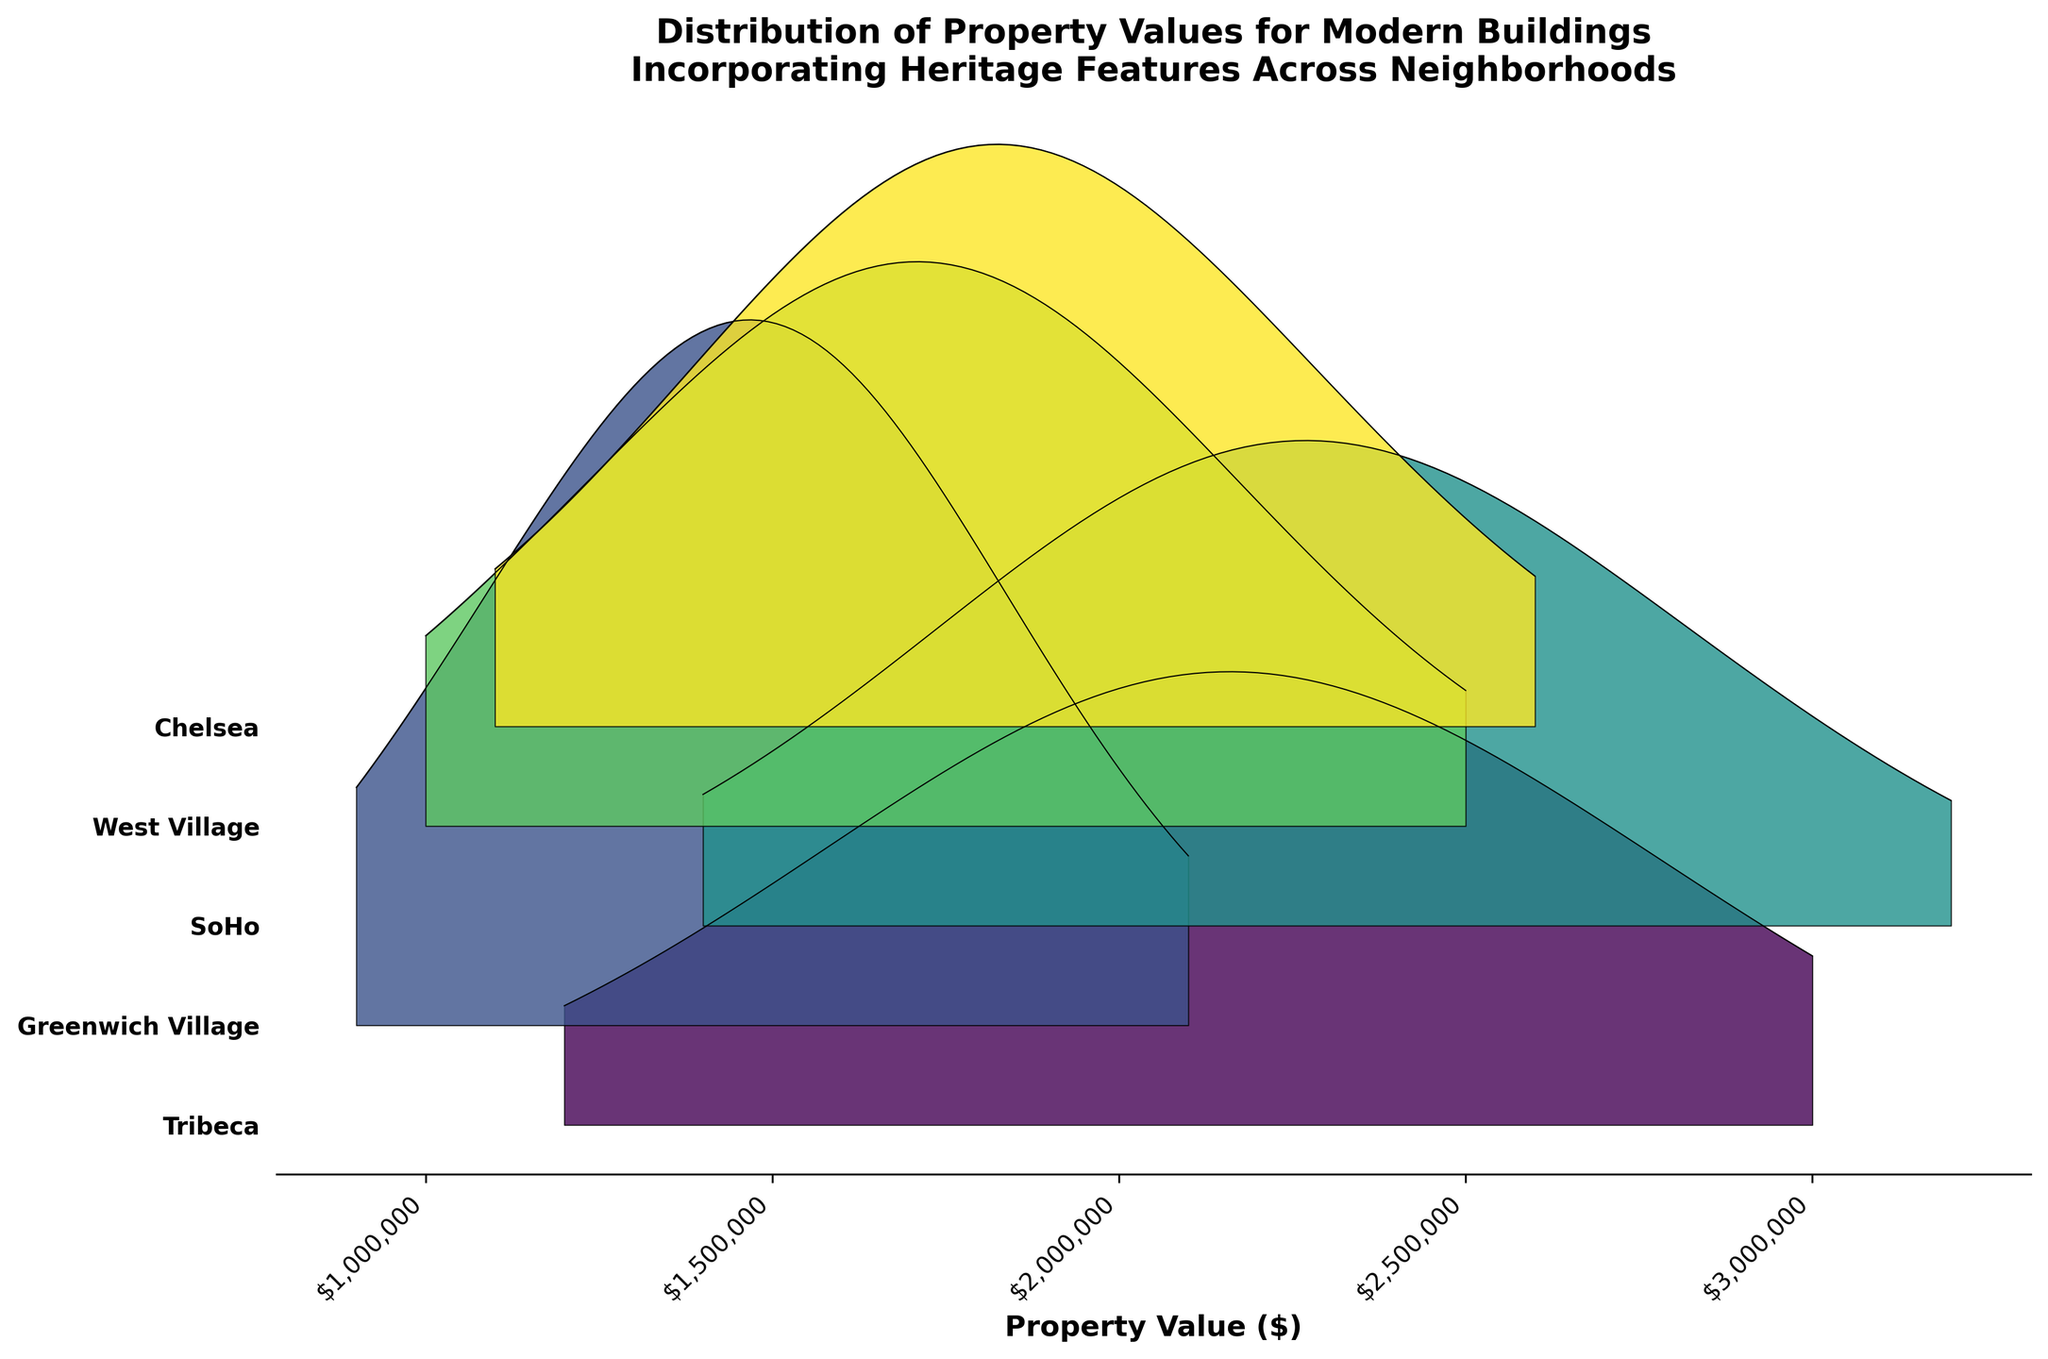What is the title of the plot? The title is the text displayed at the top of the plot. By looking at the plot, you can see the title emphasizing the distribution of property values.
Answer: Distribution of Property Values for Modern Buildings Incorporating Heritage Features Across Neighborhoods Which neighborhood shows the highest density for the highest property value? To determine this, look at the peaks of the density curves for each neighborhood and find the highest property value. The SoHo neighborhood has a peak at the highest value around $3,200,000.
Answer: SoHo What is the range of property values displayed for Greenwich Village? To find the range, look at the minimum and maximum values on the x-axis for Greenwich Village. The plot shows the property values for Greenwich Village range from $900,000 to $2,100,000.
Answer: $900,000 to $2,100,000 What is the median property value for Tribeca based on the figure? The median value can be visually approximated where the density appears balanced on either side. For Tribeca, the distribution peaks around the middle, indicating the median is around $2,100,000.
Answer: $2,100,000 Which neighborhood has the lowest visible property value? Identifying the lowest property value involves looking for the smallest x-value among all neighborhoods. Greenwich Village is the neighborhood with the lowest value displayed at $900,000.
Answer: Greenwich Village How do the property values in SoHo compare to those in Chelsea? Compare the range and peak values of the density curves for SoHo and Chelsea. SoHo values are generally higher, ranging from $1,400,000 to $3,200,000, whereas Chelsea values range from $1,100,000 to $2,600,000.
Answer: SoHo property values are higher Which neighborhood's peak density is the narrowest? To find the neighborhood with the narrowest peak, look at the width of the highest density point for each neighborhood. Greenwich Village has a sharp, narrow peak at around $1,500,000.
Answer: Greenwich Village For West Village, what property value corresponds to the highest density in the plot? Find the highest point in the density curve for West Village and check the corresponding value on the x-axis. The peak density occurs around $1,750,000.
Answer: $1,750,000 How do the property value distributions in Tribeca and West Village overlap? Look at the density curves for both Tribeca and West Village and find overlapping values. They both show considerable density around $2,000,000, indicating overlap in that range.
Answer: Around $2,000,000 Which neighborhood has the widest range of property values? Determine the neighborhood with the largest span between its minimum and maximum property values. SoHo has the widest range from $1,400,000 to $3,200,000.
Answer: SoHo 